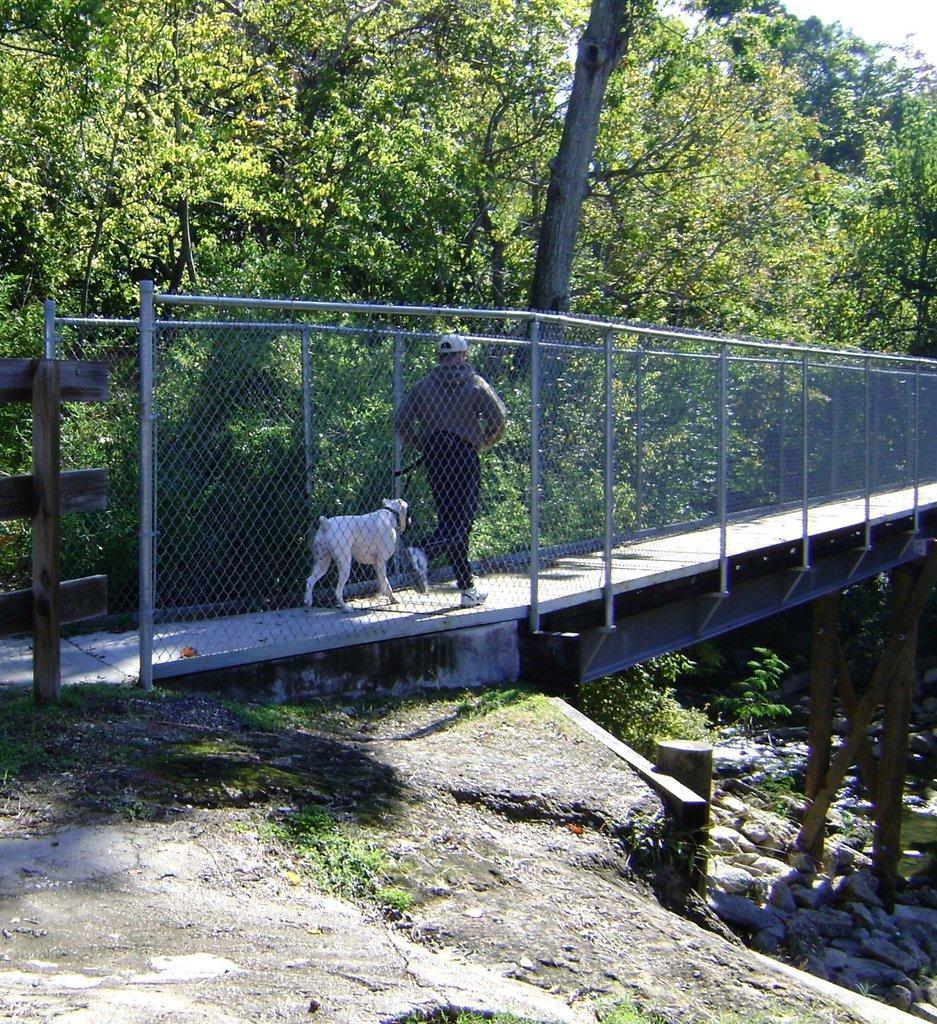Describe this image in one or two sentences. In this image we can see a person walking with a dog on the bridge and there is a fence and on the left side there are few trees and on the right side there are stones. 